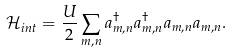<formula> <loc_0><loc_0><loc_500><loc_500>\mathcal { H } _ { i n t } = \frac { U } { 2 } \sum _ { m , n } a _ { m , n } ^ { \dagger } a _ { m , n } ^ { \dagger } a _ { m , n } a _ { m , n } .</formula> 